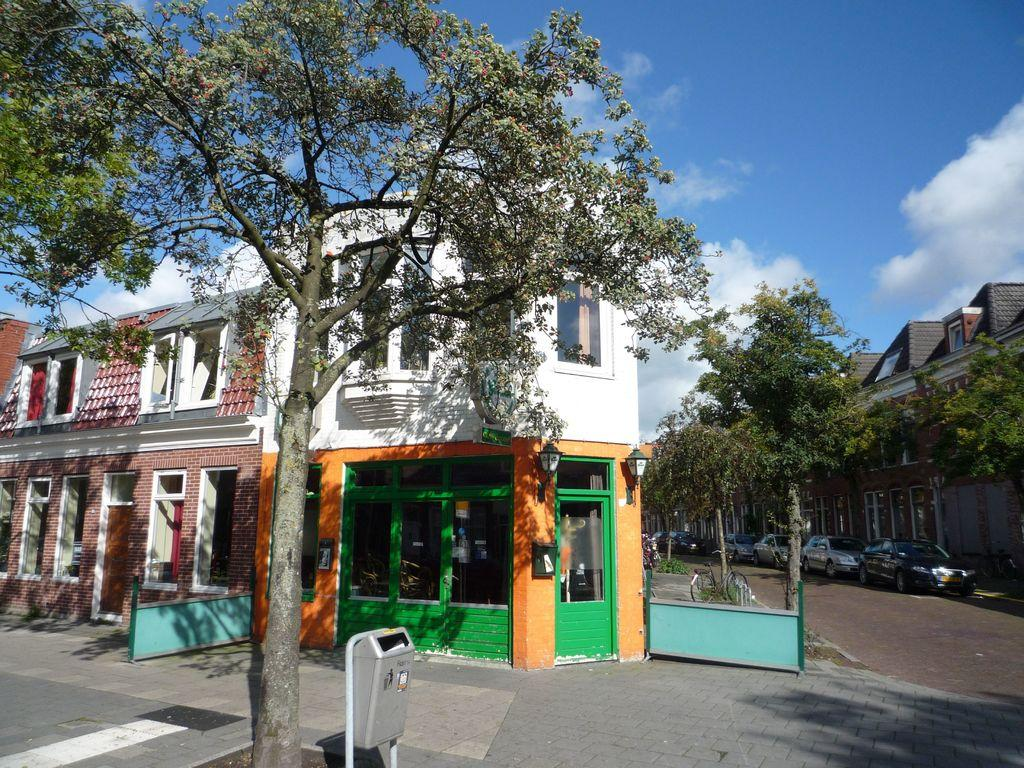What is the main structure in the middle of the image? There is a house in the middle of the image. What type of vegetation can be seen in the image? There are trees in the image. What can be seen on the right side of the image? There are cars parked on the road on the right side of the image. What is visible at the top of the image? The sky is blue in color and visible at the top of the image. Where is the bedroom located in the image? There is no bedroom present in the image. Can you see a plane flying in the sky in the image? There is no plane visible in the sky in the image. 